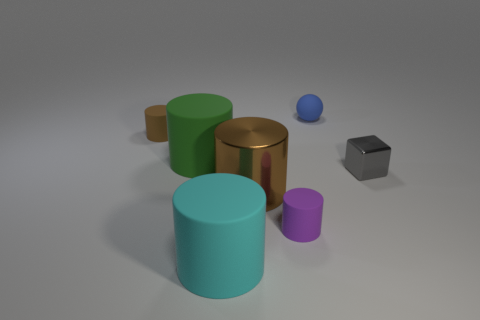Is there any object that stands out based on its shape, and if so, can you explain how? Indeed, the silver cube stands out due to its angular form. It is the only object in the image with a cuboid shape, characterized by six square faces and distinct edges, differing from the other objects which are primarily cylindrical. 